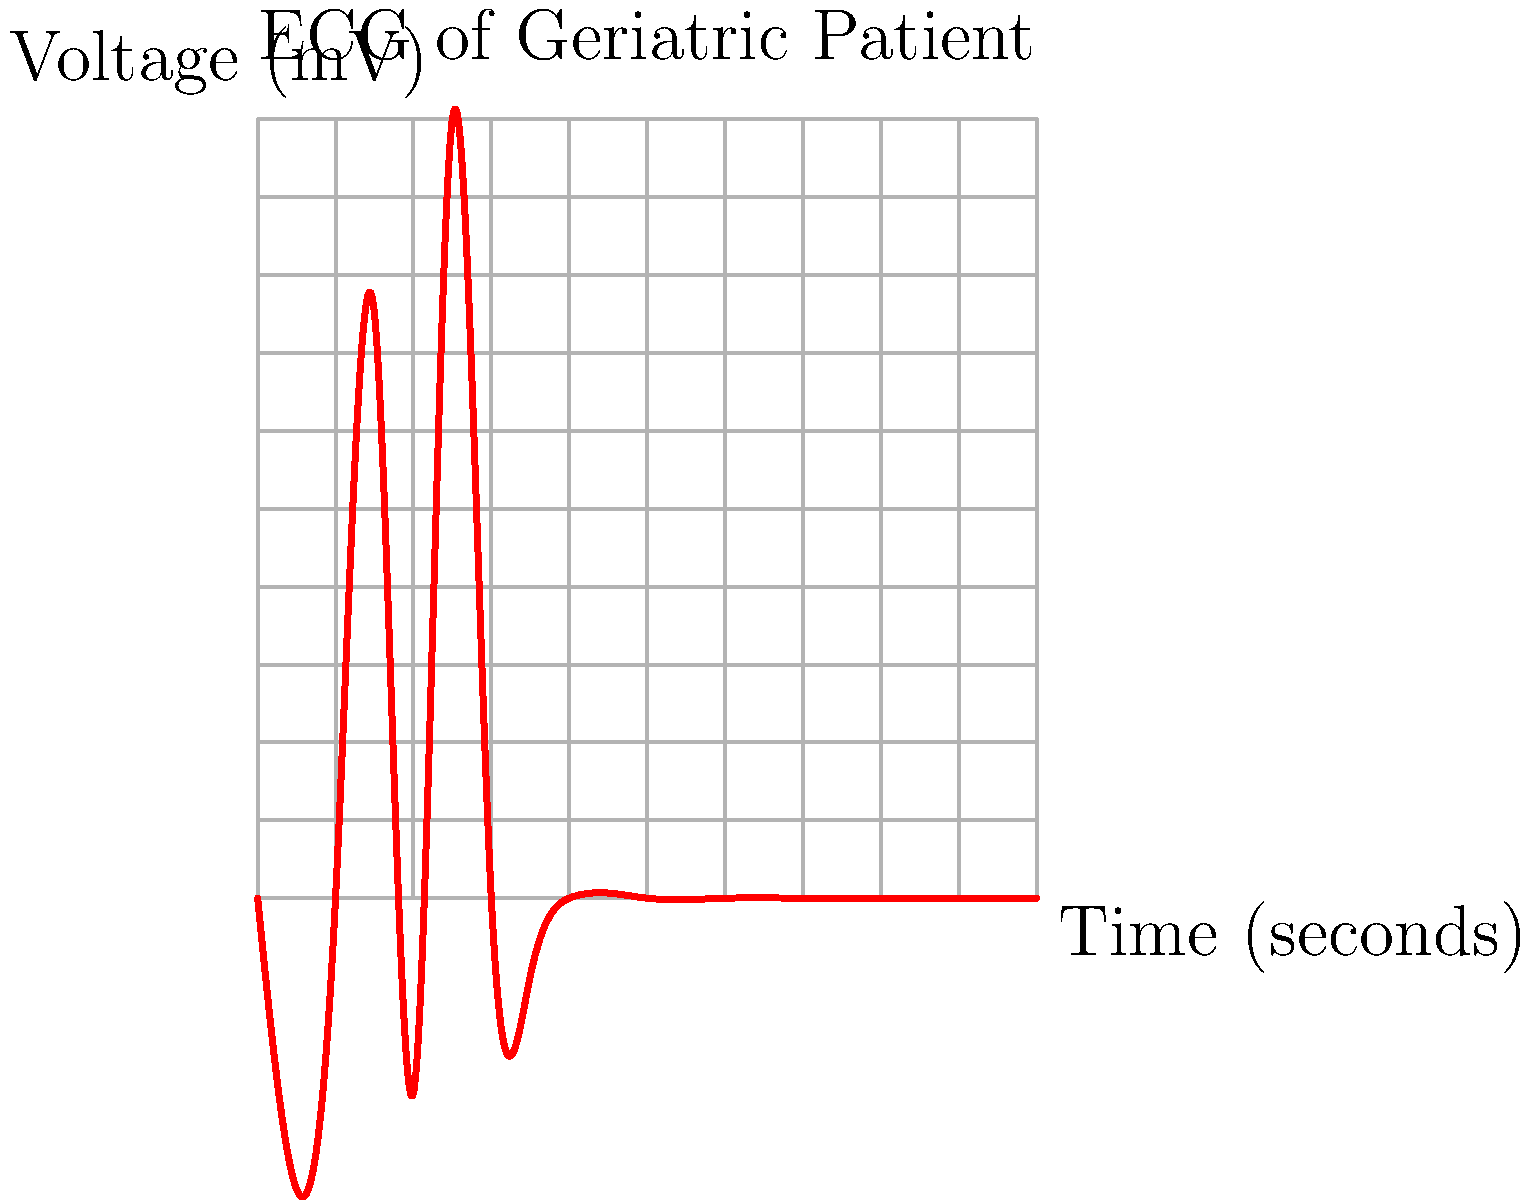Based on the ECG trace shown, what is the most likely diagnosis for this geriatric patient? To interpret this ECG and arrive at a diagnosis, let's analyze it step-by-step:

1. Rhythm: The rhythm appears regular, with consistent intervals between QRS complexes.

2. Rate: We can estimate the heart rate using the large squares (0.2 seconds each). There are about 5 large squares between QRS complexes, giving us a rate of about 60 bpm (300 / 5 = 60).

3. P waves: There are no visible P waves preceding the QRS complexes.

4. QRS complex: The QRS complexes are narrow, lasting less than 0.12 seconds, which is normal.

5. T waves: T waves are not clearly visible in this tracing.

6. QT interval: Cannot be accurately assessed due to the absence of clear T waves.

The key features of this ECG are:
- Regular rhythm
- Normal heart rate
- Absence of P waves
- Narrow QRS complexes

The absence of P waves with a regular rhythm and narrow QRS complexes is characteristic of atrial fibrillation. In atrial fibrillation, the atria are not contracting in a coordinated manner, leading to the absence of P waves. The AV node regulates the ventricular rate, resulting in a regular rhythm with narrow QRS complexes.

Atrial fibrillation is particularly common in geriatric patients, with its prevalence increasing with age. It's associated with various risk factors often present in the elderly, such as hypertension, heart failure, and valvular heart disease.
Answer: Atrial fibrillation 